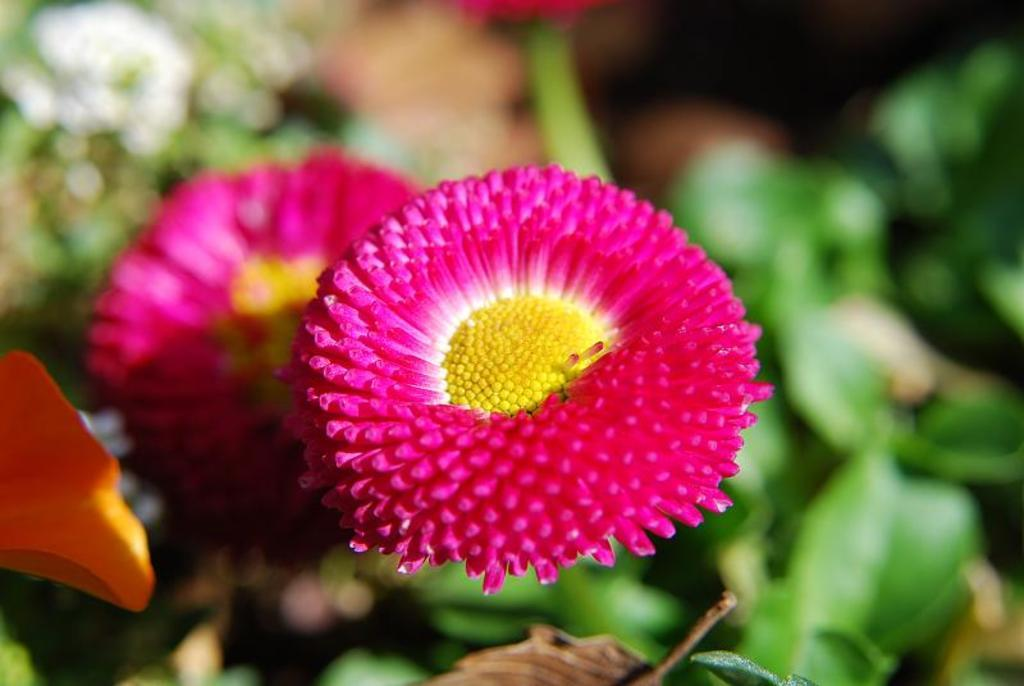What type of plants can be seen in the image? There are flowers and leaves in the image. Can you describe the background of the image? The background of the image is blurry. How many times did the flowers laugh during the week in the image? There is no indication of laughter or a specific time frame in the image, as it features flowers and leaves with a blurry background. 